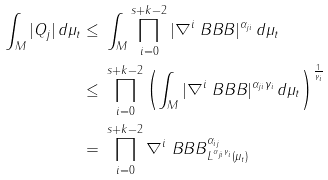Convert formula to latex. <formula><loc_0><loc_0><loc_500><loc_500>\int _ { M } | Q _ { j } | \, d \mu _ { t } \leq \, & \, \int _ { M } \prod _ { i = 0 } ^ { s + k - 2 } | \nabla ^ { i } \ B B B | ^ { \alpha _ { j i } } \, d \mu _ { t } \\ \leq \, & \, \prod _ { i = 0 } ^ { s + k - 2 } \left ( \int _ { M } | \nabla ^ { i } \ B B B | ^ { \alpha _ { j i } \gamma _ { i } } \, d \mu _ { t } \right ) ^ { \frac { 1 } { \gamma _ { i } } } \\ = \, & \, \prod _ { i = 0 } ^ { s + k - 2 } \| \nabla ^ { i } \ B B B \| _ { L ^ { \alpha _ { j i } \gamma _ { i } } ( \mu _ { t } ) } ^ { \alpha _ { i j } }</formula> 